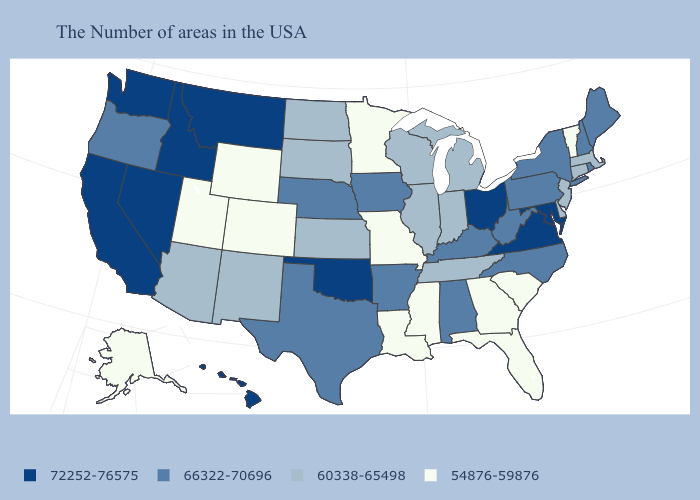Name the states that have a value in the range 72252-76575?
Quick response, please. Maryland, Virginia, Ohio, Oklahoma, Montana, Idaho, Nevada, California, Washington, Hawaii. Name the states that have a value in the range 72252-76575?
Keep it brief. Maryland, Virginia, Ohio, Oklahoma, Montana, Idaho, Nevada, California, Washington, Hawaii. How many symbols are there in the legend?
Give a very brief answer. 4. Among the states that border Idaho , does Wyoming have the lowest value?
Short answer required. Yes. Among the states that border Alabama , which have the highest value?
Be succinct. Tennessee. What is the value of Nevada?
Give a very brief answer. 72252-76575. What is the lowest value in the USA?
Quick response, please. 54876-59876. Which states hav the highest value in the West?
Short answer required. Montana, Idaho, Nevada, California, Washington, Hawaii. Among the states that border Connecticut , does Rhode Island have the highest value?
Give a very brief answer. Yes. What is the value of Oregon?
Keep it brief. 66322-70696. What is the value of Virginia?
Give a very brief answer. 72252-76575. Does Colorado have the lowest value in the West?
Concise answer only. Yes. What is the value of Arizona?
Give a very brief answer. 60338-65498. Does the map have missing data?
Short answer required. No. Among the states that border Utah , which have the highest value?
Answer briefly. Idaho, Nevada. 